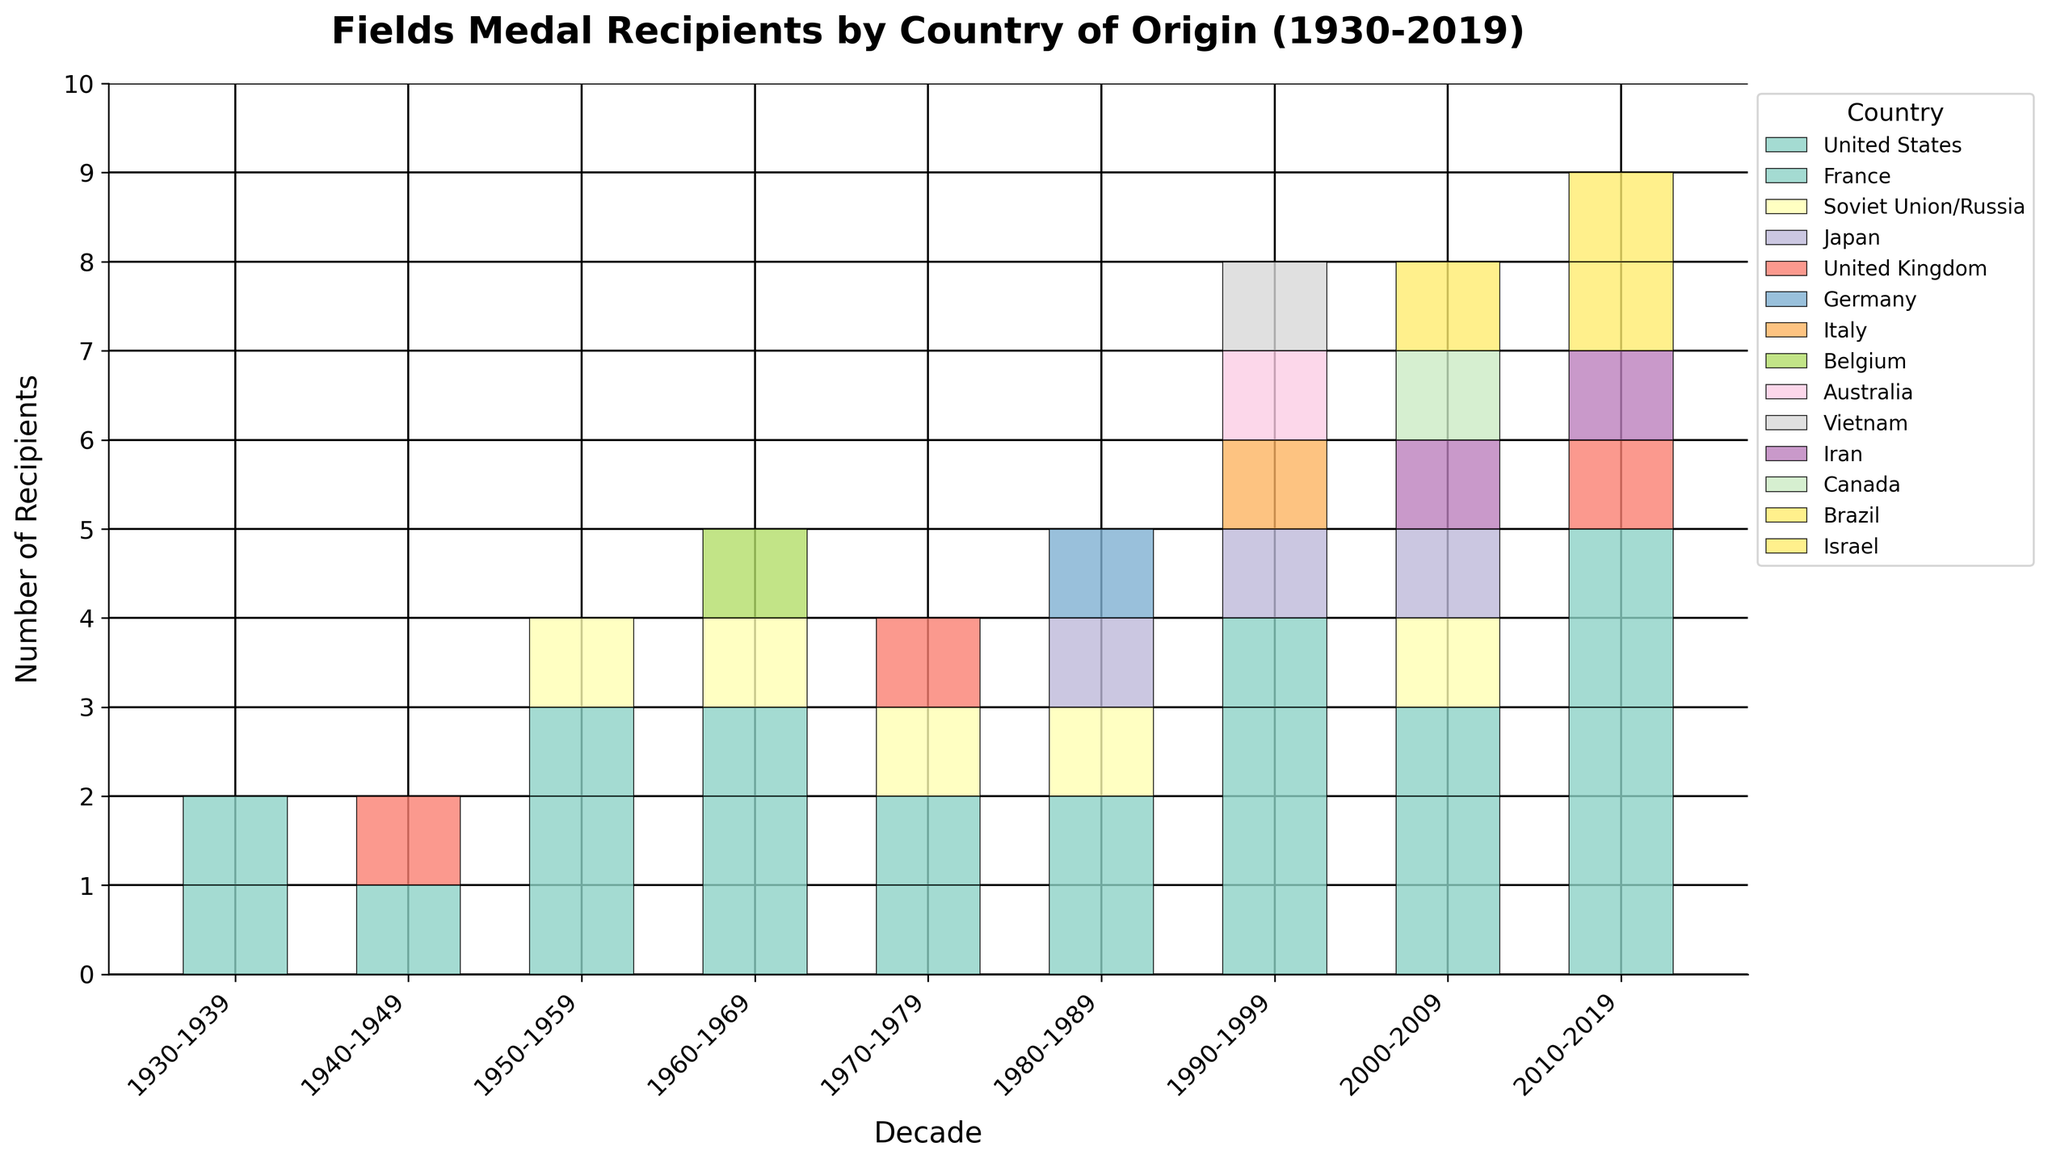Which decade had the highest number of total Fields Medal recipients? By inspecting the height of the stacked bars, the 1990-1999 decade has the tallest bar, indicating the highest number of total recipients.
Answer: 1990-1999 Which country received the most Fields Medals during the 1980s? By analyzing the distinct segments for each country in the 1980-1989 bar, the United States has the highest segment.
Answer: United States How many recipients did Japan have in total over all decades? Summing Japan's values across all decades: 0 (1930-1939) + 0 (1940-1949) + 0 (1950-1959) + 0 (1960-1969) + 0 (1970-1979) + 1 (1980-1989) + 1 (1990-1999) + 1 (2000-2009) + 0 (2010-2019). Total = 3.
Answer: 3 Were there any decades where the Soviet Union/Russia did not win any Fields Medals? Observing the values above the Soviet Union/Russia bar segment, the country received 0 medals in the 1940-1949, 1990-1999, and 2010-2019 decades.
Answer: Yes In which decade did France see the highest number of recipients? Looking at the height of France's segments across all decades, the 2010-2019 decade has the highest segment.
Answer: 2010-2019 Calculate the total number of Fields Medal recipients for the United States between 1930-2019. Summing the United States' values across all decades: 1 (1930-1939) + 1 (1940-1949) + 2 (1950-1959) + 2 (1960-1969) + 1 (1970-1979) + 2 (1980-1989) + 3 (1990-1999) + 2 (2000-2009) + 3 (2010-2019). Total = 17.
Answer: 17 Which two decades saw Italy having any Fields Medal recipients? Inspecting the bar segments for Italy, it has segments in the 1990-1999 (1 recipient).
Answer: 1990-1999 Compare the total number of Fields Medal recipients for France and Germany during the 1980s. France's recipients in the 1980-1989 decade are 0, while Germany's recipients are 1.
Answer: Germany had more Across which decades did Belgium have Fields Medal recipients? Belgium has a segment only in the 1960-1969 decade.
Answer: 1960-1969 